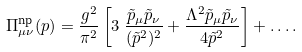<formula> <loc_0><loc_0><loc_500><loc_500>\Pi ^ { \text {np} } _ { \mu \nu } ( p ) & = \frac { g ^ { 2 } } { \pi ^ { 2 } } \left [ 3 \ \frac { \tilde { p } _ { \mu } \tilde { p } _ { \nu } } { ( \tilde { p } ^ { 2 } ) ^ { 2 } } + \frac { \Lambda ^ { 2 } \tilde { p } _ { \mu } \tilde { p } _ { \nu } } { 4 \tilde { p } ^ { 2 } } \right ] + \dots .</formula> 